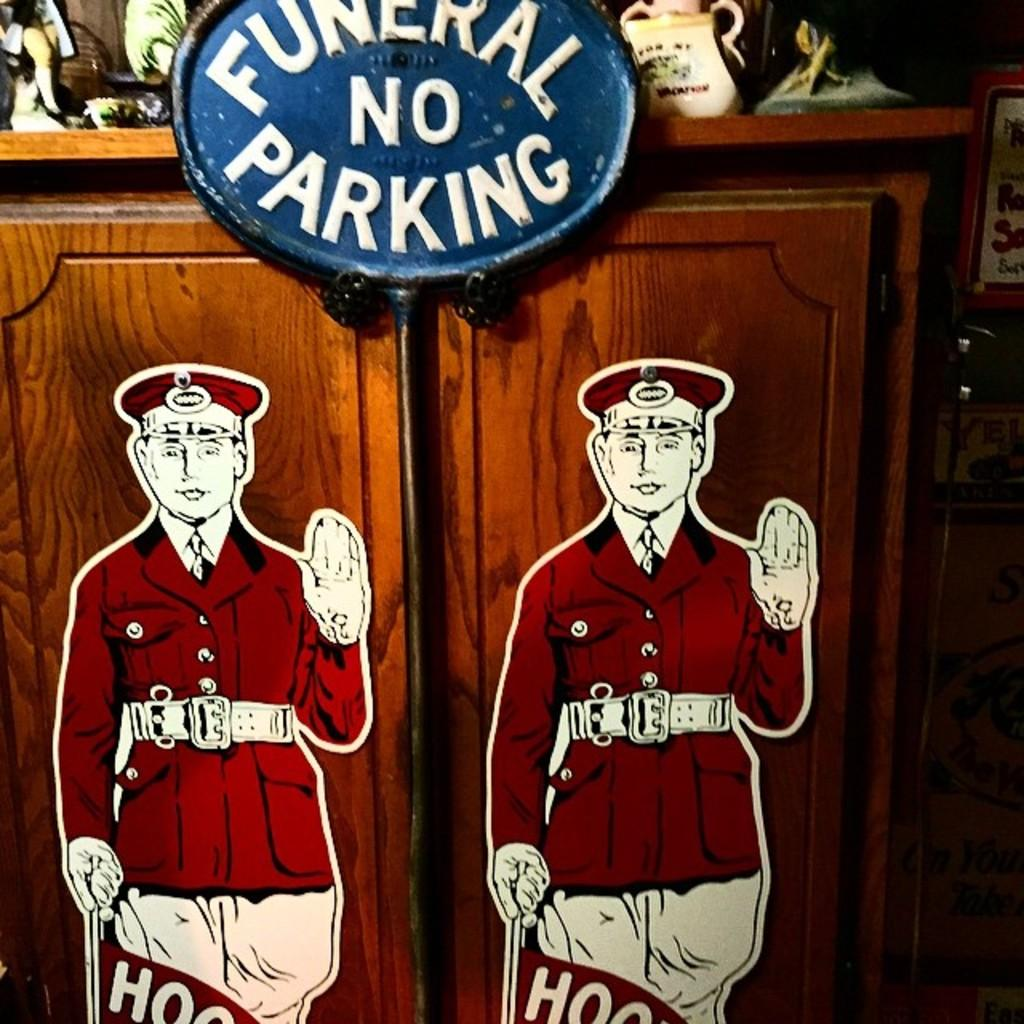<image>
Give a short and clear explanation of the subsequent image. Funeral no parking sign in blue on a cabinet. 